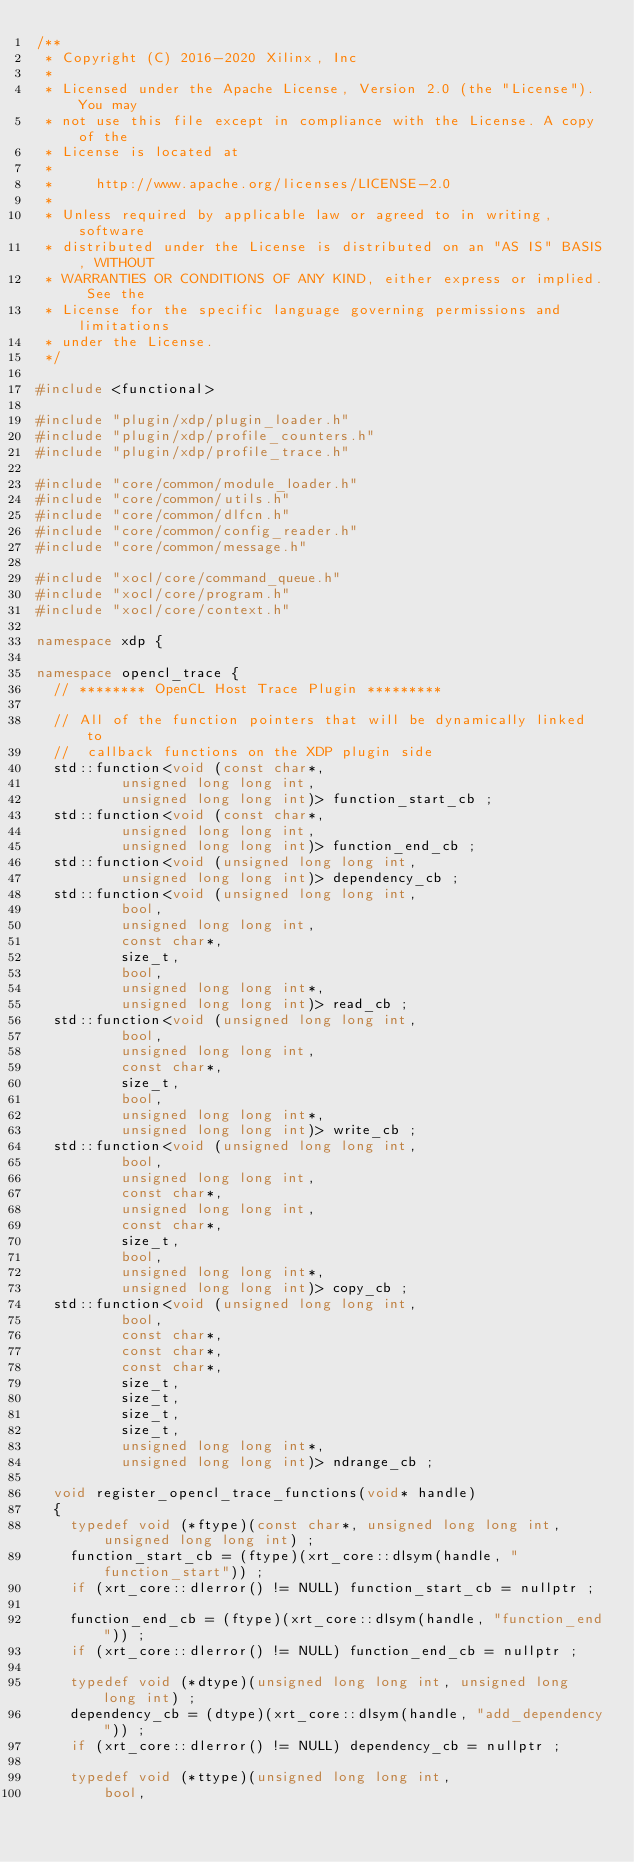Convert code to text. <code><loc_0><loc_0><loc_500><loc_500><_C++_>/**
 * Copyright (C) 2016-2020 Xilinx, Inc
 *
 * Licensed under the Apache License, Version 2.0 (the "License"). You may
 * not use this file except in compliance with the License. A copy of the
 * License is located at
 *
 *     http://www.apache.org/licenses/LICENSE-2.0
 *
 * Unless required by applicable law or agreed to in writing, software
 * distributed under the License is distributed on an "AS IS" BASIS, WITHOUT
 * WARRANTIES OR CONDITIONS OF ANY KIND, either express or implied. See the
 * License for the specific language governing permissions and limitations
 * under the License.
 */

#include <functional>

#include "plugin/xdp/plugin_loader.h"
#include "plugin/xdp/profile_counters.h" 
#include "plugin/xdp/profile_trace.h"

#include "core/common/module_loader.h"
#include "core/common/utils.h"
#include "core/common/dlfcn.h"
#include "core/common/config_reader.h"
#include "core/common/message.h"

#include "xocl/core/command_queue.h"
#include "xocl/core/program.h"
#include "xocl/core/context.h"

namespace xdp {

namespace opencl_trace {
  // ******** OpenCL Host Trace Plugin *********

  // All of the function pointers that will be dynamically linked to
  //  callback functions on the XDP plugin side
  std::function<void (const char*,
		      unsigned long long int,
		      unsigned long long int)> function_start_cb ;
  std::function<void (const char*,
		      unsigned long long int,
		      unsigned long long int)> function_end_cb ;
  std::function<void (unsigned long long int,
		      unsigned long long int)> dependency_cb ;
  std::function<void (unsigned long long int, 
		      bool, 
		      unsigned long long int, 
		      const char*, 
		      size_t, 
		      bool, 
		      unsigned long long int*, 
		      unsigned long long int)> read_cb ;
  std::function<void (unsigned long long int,
		      bool,
		      unsigned long long int,
		      const char*,
		      size_t,
		      bool,
		      unsigned long long int*,
		      unsigned long long int)> write_cb ;
  std::function<void (unsigned long long int,
		      bool,
		      unsigned long long int,
		      const char*,
		      unsigned long long int,
		      const char*,
		      size_t,
		      bool,
		      unsigned long long int*,
		      unsigned long long int)> copy_cb ;
  std::function<void (unsigned long long int,
		      bool,
		      const char*,
		      const char*,
		      const char*,
		      size_t,
		      size_t,
		      size_t,
		      size_t,
		      unsigned long long int*,
		      unsigned long long int)> ndrange_cb ;

  void register_opencl_trace_functions(void* handle)
  {
    typedef void (*ftype)(const char*, unsigned long long int, unsigned long long int) ;
    function_start_cb = (ftype)(xrt_core::dlsym(handle, "function_start")) ;
    if (xrt_core::dlerror() != NULL) function_start_cb = nullptr ;

    function_end_cb = (ftype)(xrt_core::dlsym(handle, "function_end")) ;
    if (xrt_core::dlerror() != NULL) function_end_cb = nullptr ;

    typedef void (*dtype)(unsigned long long int, unsigned long long int) ;
    dependency_cb = (dtype)(xrt_core::dlsym(handle, "add_dependency")) ;
    if (xrt_core::dlerror() != NULL) dependency_cb = nullptr ;

    typedef void (*ttype)(unsigned long long int,
			  bool,</code> 